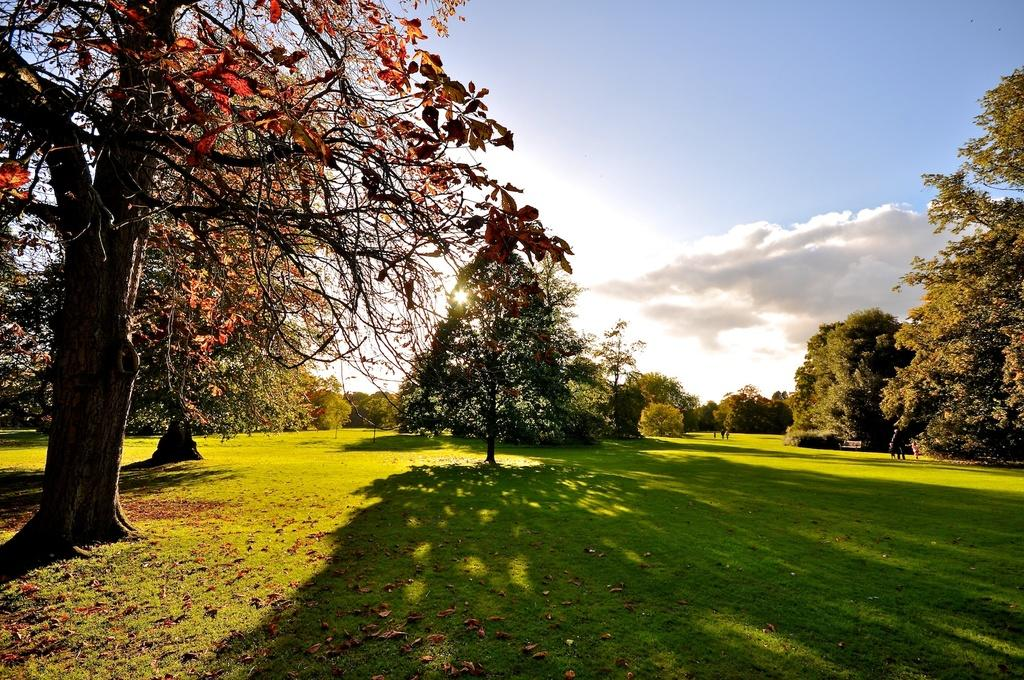Where was the image taken? The image was taken at an open ground. What type of vegetation is present on the ground? There is green grass on the ground. What else can be seen in the image besides the grass? There are trees in the image. What is visible at the top of the image? The sky is visible at the top of the image. What type of hat is the pump wearing in the image? There is no hat or pump present in the image. Can you describe the table in the image? There is no table present in the image. 